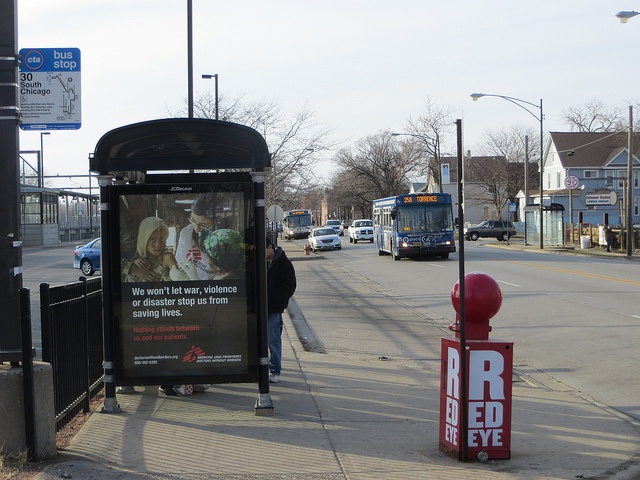Describe the objects in this image and their specific colors. I can see bus in black, gray, navy, and darkgray tones, people in black, navy, gray, and darkblue tones, people in black and gray tones, people in black, gray, darkgray, and teal tones, and people in black and gray tones in this image. 